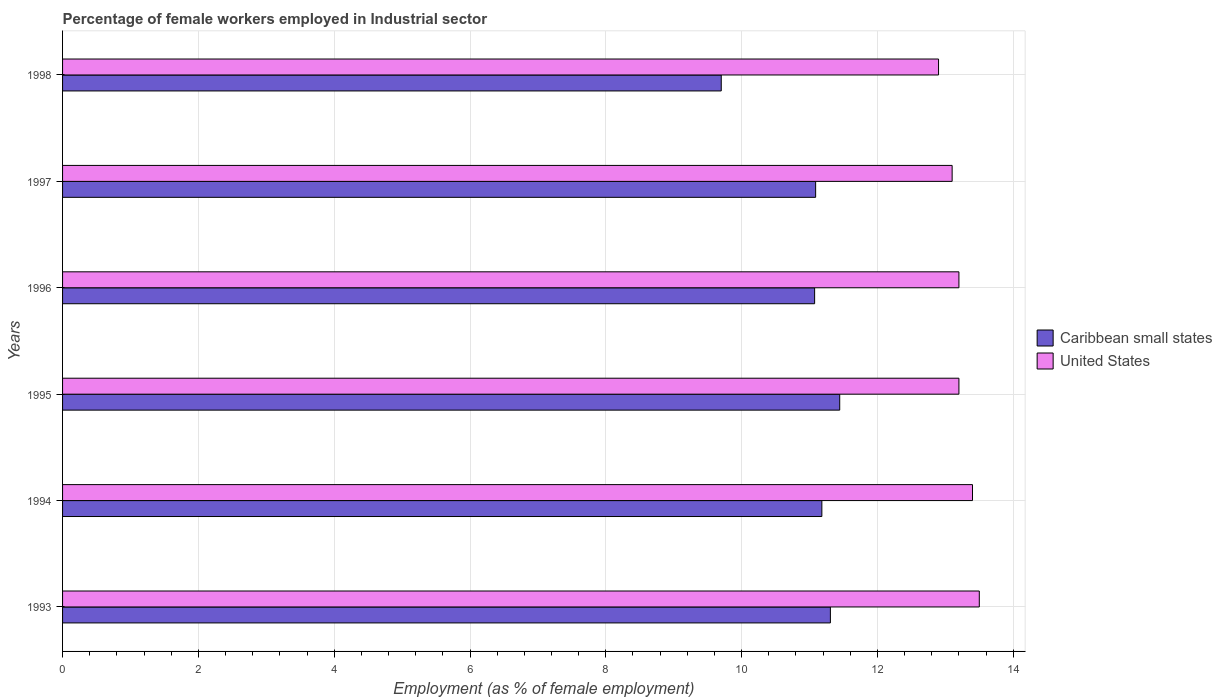Are the number of bars per tick equal to the number of legend labels?
Offer a very short reply. Yes. How many bars are there on the 4th tick from the top?
Make the answer very short. 2. How many bars are there on the 5th tick from the bottom?
Ensure brevity in your answer.  2. In how many cases, is the number of bars for a given year not equal to the number of legend labels?
Make the answer very short. 0. What is the percentage of females employed in Industrial sector in Caribbean small states in 1996?
Give a very brief answer. 11.07. Across all years, what is the maximum percentage of females employed in Industrial sector in Caribbean small states?
Make the answer very short. 11.44. Across all years, what is the minimum percentage of females employed in Industrial sector in Caribbean small states?
Provide a short and direct response. 9.7. What is the total percentage of females employed in Industrial sector in Caribbean small states in the graph?
Give a very brief answer. 65.8. What is the difference between the percentage of females employed in Industrial sector in United States in 1994 and that in 1997?
Give a very brief answer. 0.3. What is the difference between the percentage of females employed in Industrial sector in United States in 1993 and the percentage of females employed in Industrial sector in Caribbean small states in 1994?
Your answer should be very brief. 2.32. What is the average percentage of females employed in Industrial sector in Caribbean small states per year?
Offer a terse response. 10.97. In the year 1998, what is the difference between the percentage of females employed in Industrial sector in United States and percentage of females employed in Industrial sector in Caribbean small states?
Give a very brief answer. 3.2. What is the ratio of the percentage of females employed in Industrial sector in United States in 1996 to that in 1998?
Make the answer very short. 1.02. Is the difference between the percentage of females employed in Industrial sector in United States in 1994 and 1996 greater than the difference between the percentage of females employed in Industrial sector in Caribbean small states in 1994 and 1996?
Make the answer very short. Yes. What is the difference between the highest and the second highest percentage of females employed in Industrial sector in Caribbean small states?
Your response must be concise. 0.14. What is the difference between the highest and the lowest percentage of females employed in Industrial sector in Caribbean small states?
Provide a succinct answer. 1.74. Is the sum of the percentage of females employed in Industrial sector in Caribbean small states in 1994 and 1996 greater than the maximum percentage of females employed in Industrial sector in United States across all years?
Your answer should be compact. Yes. What does the 1st bar from the top in 1993 represents?
Give a very brief answer. United States. What does the 1st bar from the bottom in 1994 represents?
Offer a very short reply. Caribbean small states. Are all the bars in the graph horizontal?
Keep it short and to the point. Yes. How many years are there in the graph?
Offer a terse response. 6. What is the difference between two consecutive major ticks on the X-axis?
Your answer should be very brief. 2. Does the graph contain grids?
Make the answer very short. Yes. How are the legend labels stacked?
Keep it short and to the point. Vertical. What is the title of the graph?
Your answer should be very brief. Percentage of female workers employed in Industrial sector. Does "Equatorial Guinea" appear as one of the legend labels in the graph?
Your answer should be compact. No. What is the label or title of the X-axis?
Ensure brevity in your answer.  Employment (as % of female employment). What is the label or title of the Y-axis?
Your response must be concise. Years. What is the Employment (as % of female employment) in Caribbean small states in 1993?
Your answer should be very brief. 11.31. What is the Employment (as % of female employment) of Caribbean small states in 1994?
Offer a very short reply. 11.18. What is the Employment (as % of female employment) of United States in 1994?
Give a very brief answer. 13.4. What is the Employment (as % of female employment) of Caribbean small states in 1995?
Provide a short and direct response. 11.44. What is the Employment (as % of female employment) of United States in 1995?
Your response must be concise. 13.2. What is the Employment (as % of female employment) in Caribbean small states in 1996?
Your answer should be compact. 11.07. What is the Employment (as % of female employment) of United States in 1996?
Your response must be concise. 13.2. What is the Employment (as % of female employment) of Caribbean small states in 1997?
Make the answer very short. 11.09. What is the Employment (as % of female employment) in United States in 1997?
Provide a short and direct response. 13.1. What is the Employment (as % of female employment) of Caribbean small states in 1998?
Offer a very short reply. 9.7. What is the Employment (as % of female employment) of United States in 1998?
Offer a very short reply. 12.9. Across all years, what is the maximum Employment (as % of female employment) of Caribbean small states?
Keep it short and to the point. 11.44. Across all years, what is the minimum Employment (as % of female employment) in Caribbean small states?
Provide a succinct answer. 9.7. Across all years, what is the minimum Employment (as % of female employment) of United States?
Your response must be concise. 12.9. What is the total Employment (as % of female employment) in Caribbean small states in the graph?
Give a very brief answer. 65.8. What is the total Employment (as % of female employment) of United States in the graph?
Offer a very short reply. 79.3. What is the difference between the Employment (as % of female employment) of Caribbean small states in 1993 and that in 1994?
Your response must be concise. 0.13. What is the difference between the Employment (as % of female employment) of United States in 1993 and that in 1994?
Ensure brevity in your answer.  0.1. What is the difference between the Employment (as % of female employment) in Caribbean small states in 1993 and that in 1995?
Offer a very short reply. -0.14. What is the difference between the Employment (as % of female employment) of Caribbean small states in 1993 and that in 1996?
Your answer should be very brief. 0.23. What is the difference between the Employment (as % of female employment) in Caribbean small states in 1993 and that in 1997?
Provide a succinct answer. 0.22. What is the difference between the Employment (as % of female employment) of Caribbean small states in 1993 and that in 1998?
Your answer should be very brief. 1.61. What is the difference between the Employment (as % of female employment) in United States in 1993 and that in 1998?
Keep it short and to the point. 0.6. What is the difference between the Employment (as % of female employment) of Caribbean small states in 1994 and that in 1995?
Your answer should be compact. -0.26. What is the difference between the Employment (as % of female employment) in Caribbean small states in 1994 and that in 1996?
Offer a very short reply. 0.11. What is the difference between the Employment (as % of female employment) in United States in 1994 and that in 1996?
Your answer should be very brief. 0.2. What is the difference between the Employment (as % of female employment) of Caribbean small states in 1994 and that in 1997?
Your answer should be compact. 0.09. What is the difference between the Employment (as % of female employment) of Caribbean small states in 1994 and that in 1998?
Offer a very short reply. 1.48. What is the difference between the Employment (as % of female employment) of Caribbean small states in 1995 and that in 1996?
Your answer should be very brief. 0.37. What is the difference between the Employment (as % of female employment) of United States in 1995 and that in 1996?
Your answer should be compact. 0. What is the difference between the Employment (as % of female employment) in Caribbean small states in 1995 and that in 1997?
Provide a succinct answer. 0.35. What is the difference between the Employment (as % of female employment) in Caribbean small states in 1995 and that in 1998?
Your answer should be compact. 1.74. What is the difference between the Employment (as % of female employment) of United States in 1995 and that in 1998?
Your answer should be compact. 0.3. What is the difference between the Employment (as % of female employment) of Caribbean small states in 1996 and that in 1997?
Provide a short and direct response. -0.01. What is the difference between the Employment (as % of female employment) in Caribbean small states in 1996 and that in 1998?
Offer a very short reply. 1.37. What is the difference between the Employment (as % of female employment) in United States in 1996 and that in 1998?
Provide a succinct answer. 0.3. What is the difference between the Employment (as % of female employment) in Caribbean small states in 1997 and that in 1998?
Offer a terse response. 1.39. What is the difference between the Employment (as % of female employment) in United States in 1997 and that in 1998?
Ensure brevity in your answer.  0.2. What is the difference between the Employment (as % of female employment) in Caribbean small states in 1993 and the Employment (as % of female employment) in United States in 1994?
Provide a short and direct response. -2.09. What is the difference between the Employment (as % of female employment) of Caribbean small states in 1993 and the Employment (as % of female employment) of United States in 1995?
Offer a very short reply. -1.89. What is the difference between the Employment (as % of female employment) in Caribbean small states in 1993 and the Employment (as % of female employment) in United States in 1996?
Give a very brief answer. -1.89. What is the difference between the Employment (as % of female employment) in Caribbean small states in 1993 and the Employment (as % of female employment) in United States in 1997?
Offer a very short reply. -1.79. What is the difference between the Employment (as % of female employment) of Caribbean small states in 1993 and the Employment (as % of female employment) of United States in 1998?
Provide a succinct answer. -1.59. What is the difference between the Employment (as % of female employment) of Caribbean small states in 1994 and the Employment (as % of female employment) of United States in 1995?
Provide a succinct answer. -2.02. What is the difference between the Employment (as % of female employment) of Caribbean small states in 1994 and the Employment (as % of female employment) of United States in 1996?
Your response must be concise. -2.02. What is the difference between the Employment (as % of female employment) of Caribbean small states in 1994 and the Employment (as % of female employment) of United States in 1997?
Offer a very short reply. -1.92. What is the difference between the Employment (as % of female employment) of Caribbean small states in 1994 and the Employment (as % of female employment) of United States in 1998?
Offer a very short reply. -1.72. What is the difference between the Employment (as % of female employment) in Caribbean small states in 1995 and the Employment (as % of female employment) in United States in 1996?
Offer a very short reply. -1.76. What is the difference between the Employment (as % of female employment) of Caribbean small states in 1995 and the Employment (as % of female employment) of United States in 1997?
Your response must be concise. -1.66. What is the difference between the Employment (as % of female employment) of Caribbean small states in 1995 and the Employment (as % of female employment) of United States in 1998?
Offer a very short reply. -1.46. What is the difference between the Employment (as % of female employment) in Caribbean small states in 1996 and the Employment (as % of female employment) in United States in 1997?
Provide a short and direct response. -2.02. What is the difference between the Employment (as % of female employment) in Caribbean small states in 1996 and the Employment (as % of female employment) in United States in 1998?
Keep it short and to the point. -1.82. What is the difference between the Employment (as % of female employment) of Caribbean small states in 1997 and the Employment (as % of female employment) of United States in 1998?
Your answer should be very brief. -1.81. What is the average Employment (as % of female employment) in Caribbean small states per year?
Give a very brief answer. 10.97. What is the average Employment (as % of female employment) of United States per year?
Give a very brief answer. 13.22. In the year 1993, what is the difference between the Employment (as % of female employment) in Caribbean small states and Employment (as % of female employment) in United States?
Offer a terse response. -2.19. In the year 1994, what is the difference between the Employment (as % of female employment) in Caribbean small states and Employment (as % of female employment) in United States?
Provide a short and direct response. -2.22. In the year 1995, what is the difference between the Employment (as % of female employment) of Caribbean small states and Employment (as % of female employment) of United States?
Offer a terse response. -1.76. In the year 1996, what is the difference between the Employment (as % of female employment) of Caribbean small states and Employment (as % of female employment) of United States?
Your answer should be compact. -2.12. In the year 1997, what is the difference between the Employment (as % of female employment) of Caribbean small states and Employment (as % of female employment) of United States?
Make the answer very short. -2.01. In the year 1998, what is the difference between the Employment (as % of female employment) of Caribbean small states and Employment (as % of female employment) of United States?
Keep it short and to the point. -3.2. What is the ratio of the Employment (as % of female employment) of Caribbean small states in 1993 to that in 1994?
Offer a terse response. 1.01. What is the ratio of the Employment (as % of female employment) of United States in 1993 to that in 1994?
Ensure brevity in your answer.  1.01. What is the ratio of the Employment (as % of female employment) in Caribbean small states in 1993 to that in 1995?
Provide a succinct answer. 0.99. What is the ratio of the Employment (as % of female employment) in United States in 1993 to that in 1995?
Make the answer very short. 1.02. What is the ratio of the Employment (as % of female employment) in United States in 1993 to that in 1996?
Ensure brevity in your answer.  1.02. What is the ratio of the Employment (as % of female employment) of Caribbean small states in 1993 to that in 1997?
Offer a terse response. 1.02. What is the ratio of the Employment (as % of female employment) of United States in 1993 to that in 1997?
Provide a succinct answer. 1.03. What is the ratio of the Employment (as % of female employment) in Caribbean small states in 1993 to that in 1998?
Offer a very short reply. 1.17. What is the ratio of the Employment (as % of female employment) in United States in 1993 to that in 1998?
Keep it short and to the point. 1.05. What is the ratio of the Employment (as % of female employment) of Caribbean small states in 1994 to that in 1995?
Your answer should be very brief. 0.98. What is the ratio of the Employment (as % of female employment) in United States in 1994 to that in 1995?
Keep it short and to the point. 1.02. What is the ratio of the Employment (as % of female employment) in Caribbean small states in 1994 to that in 1996?
Offer a terse response. 1.01. What is the ratio of the Employment (as % of female employment) in United States in 1994 to that in 1996?
Your answer should be very brief. 1.02. What is the ratio of the Employment (as % of female employment) in Caribbean small states in 1994 to that in 1997?
Give a very brief answer. 1.01. What is the ratio of the Employment (as % of female employment) of United States in 1994 to that in 1997?
Offer a terse response. 1.02. What is the ratio of the Employment (as % of female employment) in Caribbean small states in 1994 to that in 1998?
Provide a short and direct response. 1.15. What is the ratio of the Employment (as % of female employment) of United States in 1994 to that in 1998?
Your response must be concise. 1.04. What is the ratio of the Employment (as % of female employment) of Caribbean small states in 1995 to that in 1996?
Your response must be concise. 1.03. What is the ratio of the Employment (as % of female employment) in United States in 1995 to that in 1996?
Your answer should be compact. 1. What is the ratio of the Employment (as % of female employment) of Caribbean small states in 1995 to that in 1997?
Provide a succinct answer. 1.03. What is the ratio of the Employment (as % of female employment) in United States in 1995 to that in 1997?
Give a very brief answer. 1.01. What is the ratio of the Employment (as % of female employment) of Caribbean small states in 1995 to that in 1998?
Your answer should be very brief. 1.18. What is the ratio of the Employment (as % of female employment) in United States in 1995 to that in 1998?
Your answer should be compact. 1.02. What is the ratio of the Employment (as % of female employment) of United States in 1996 to that in 1997?
Make the answer very short. 1.01. What is the ratio of the Employment (as % of female employment) in Caribbean small states in 1996 to that in 1998?
Keep it short and to the point. 1.14. What is the ratio of the Employment (as % of female employment) in United States in 1996 to that in 1998?
Provide a short and direct response. 1.02. What is the ratio of the Employment (as % of female employment) in Caribbean small states in 1997 to that in 1998?
Your answer should be compact. 1.14. What is the ratio of the Employment (as % of female employment) of United States in 1997 to that in 1998?
Provide a short and direct response. 1.02. What is the difference between the highest and the second highest Employment (as % of female employment) of Caribbean small states?
Make the answer very short. 0.14. What is the difference between the highest and the second highest Employment (as % of female employment) in United States?
Ensure brevity in your answer.  0.1. What is the difference between the highest and the lowest Employment (as % of female employment) of Caribbean small states?
Offer a very short reply. 1.74. What is the difference between the highest and the lowest Employment (as % of female employment) in United States?
Your response must be concise. 0.6. 